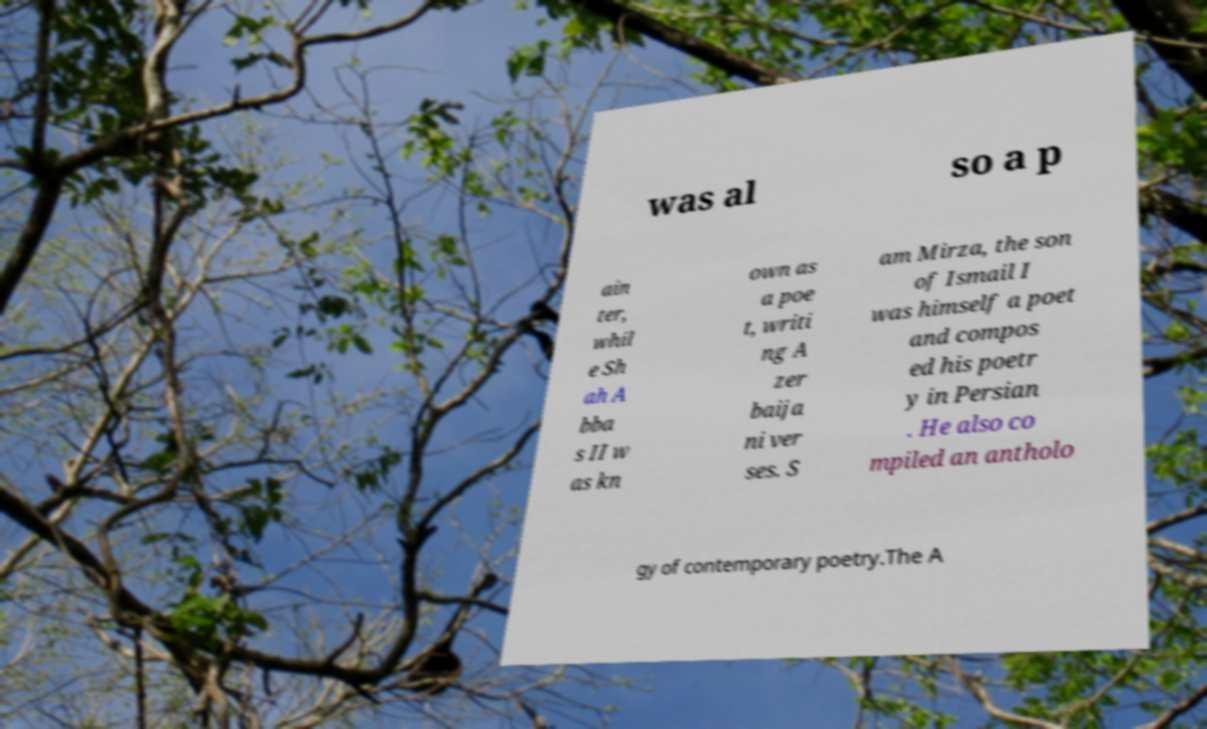Can you accurately transcribe the text from the provided image for me? was al so a p ain ter, whil e Sh ah A bba s II w as kn own as a poe t, writi ng A zer baija ni ver ses. S am Mirza, the son of Ismail I was himself a poet and compos ed his poetr y in Persian . He also co mpiled an antholo gy of contemporary poetry.The A 